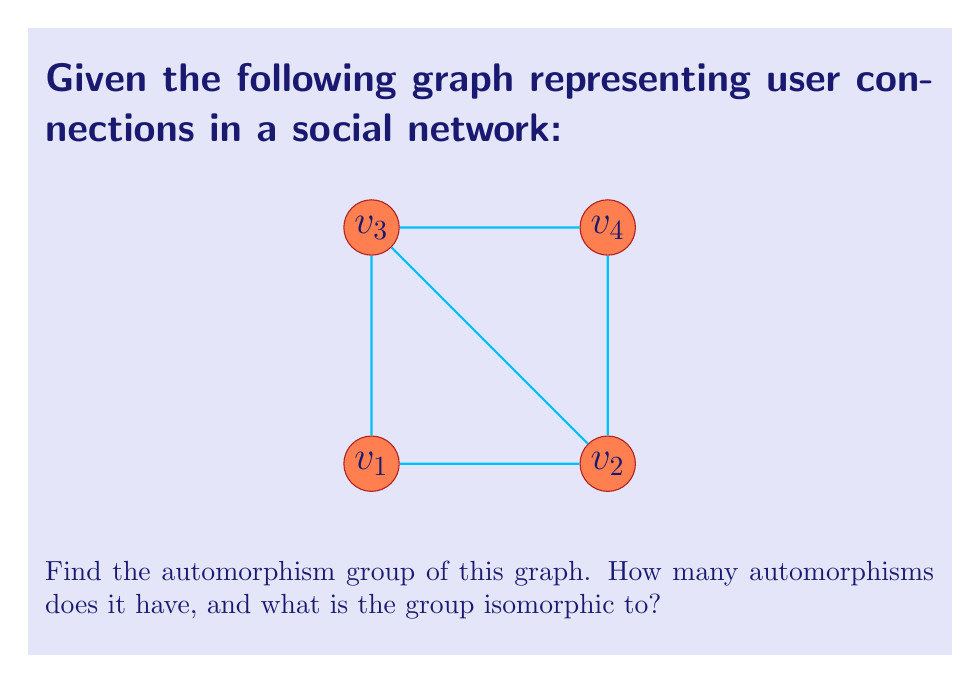What is the answer to this math problem? To find the automorphism group of this graph, we need to follow these steps:

1) First, let's identify the symmetries of the graph:
   - The graph has a rotational symmetry of 180 degrees around its center.
   - It also has two reflection symmetries: one about the vertical axis and one about the horizontal axis.

2) Let's list all possible automorphisms:
   - Identity: $(v_1)(v_2)(v_3)(v_4)$
   - 180-degree rotation: $(v_1 v_3)(v_2 v_4)$
   - Vertical reflection: $(v_1 v_2)(v_3 v_4)$
   - Horizontal reflection: $(v_1 v_4)(v_2 v_3)$

3) We can verify that these are indeed all the automorphisms by checking that they preserve the adjacency relations of the graph.

4) The number of automorphisms is 4.

5) To determine what group this is isomorphic to, we need to look at its structure:
   - It has 4 elements
   - Each element is its own inverse
   - The product of any two non-identity elements gives the third non-identity element

6) This structure matches the Klein four-group, also known as $V_4$ or $\mathbb{Z}_2 \times \mathbb{Z}_2$.

Therefore, the automorphism group of this graph is isomorphic to the Klein four-group.
Answer: The automorphism group has 4 elements and is isomorphic to $V_4$ (Klein four-group). 